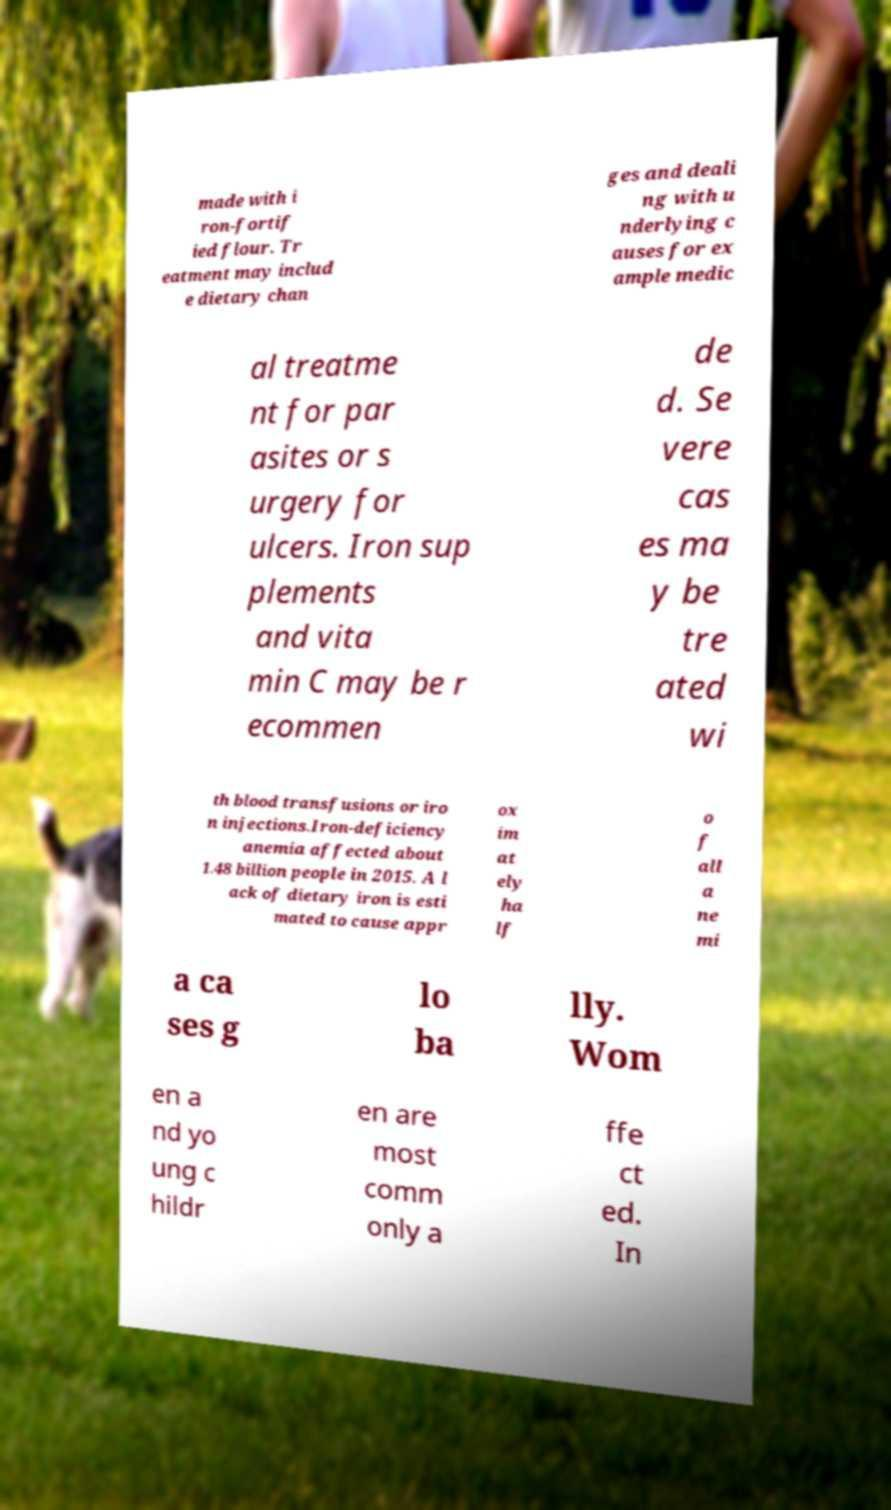Please read and relay the text visible in this image. What does it say? made with i ron-fortif ied flour. Tr eatment may includ e dietary chan ges and deali ng with u nderlying c auses for ex ample medic al treatme nt for par asites or s urgery for ulcers. Iron sup plements and vita min C may be r ecommen de d. Se vere cas es ma y be tre ated wi th blood transfusions or iro n injections.Iron-deficiency anemia affected about 1.48 billion people in 2015. A l ack of dietary iron is esti mated to cause appr ox im at ely ha lf o f all a ne mi a ca ses g lo ba lly. Wom en a nd yo ung c hildr en are most comm only a ffe ct ed. In 